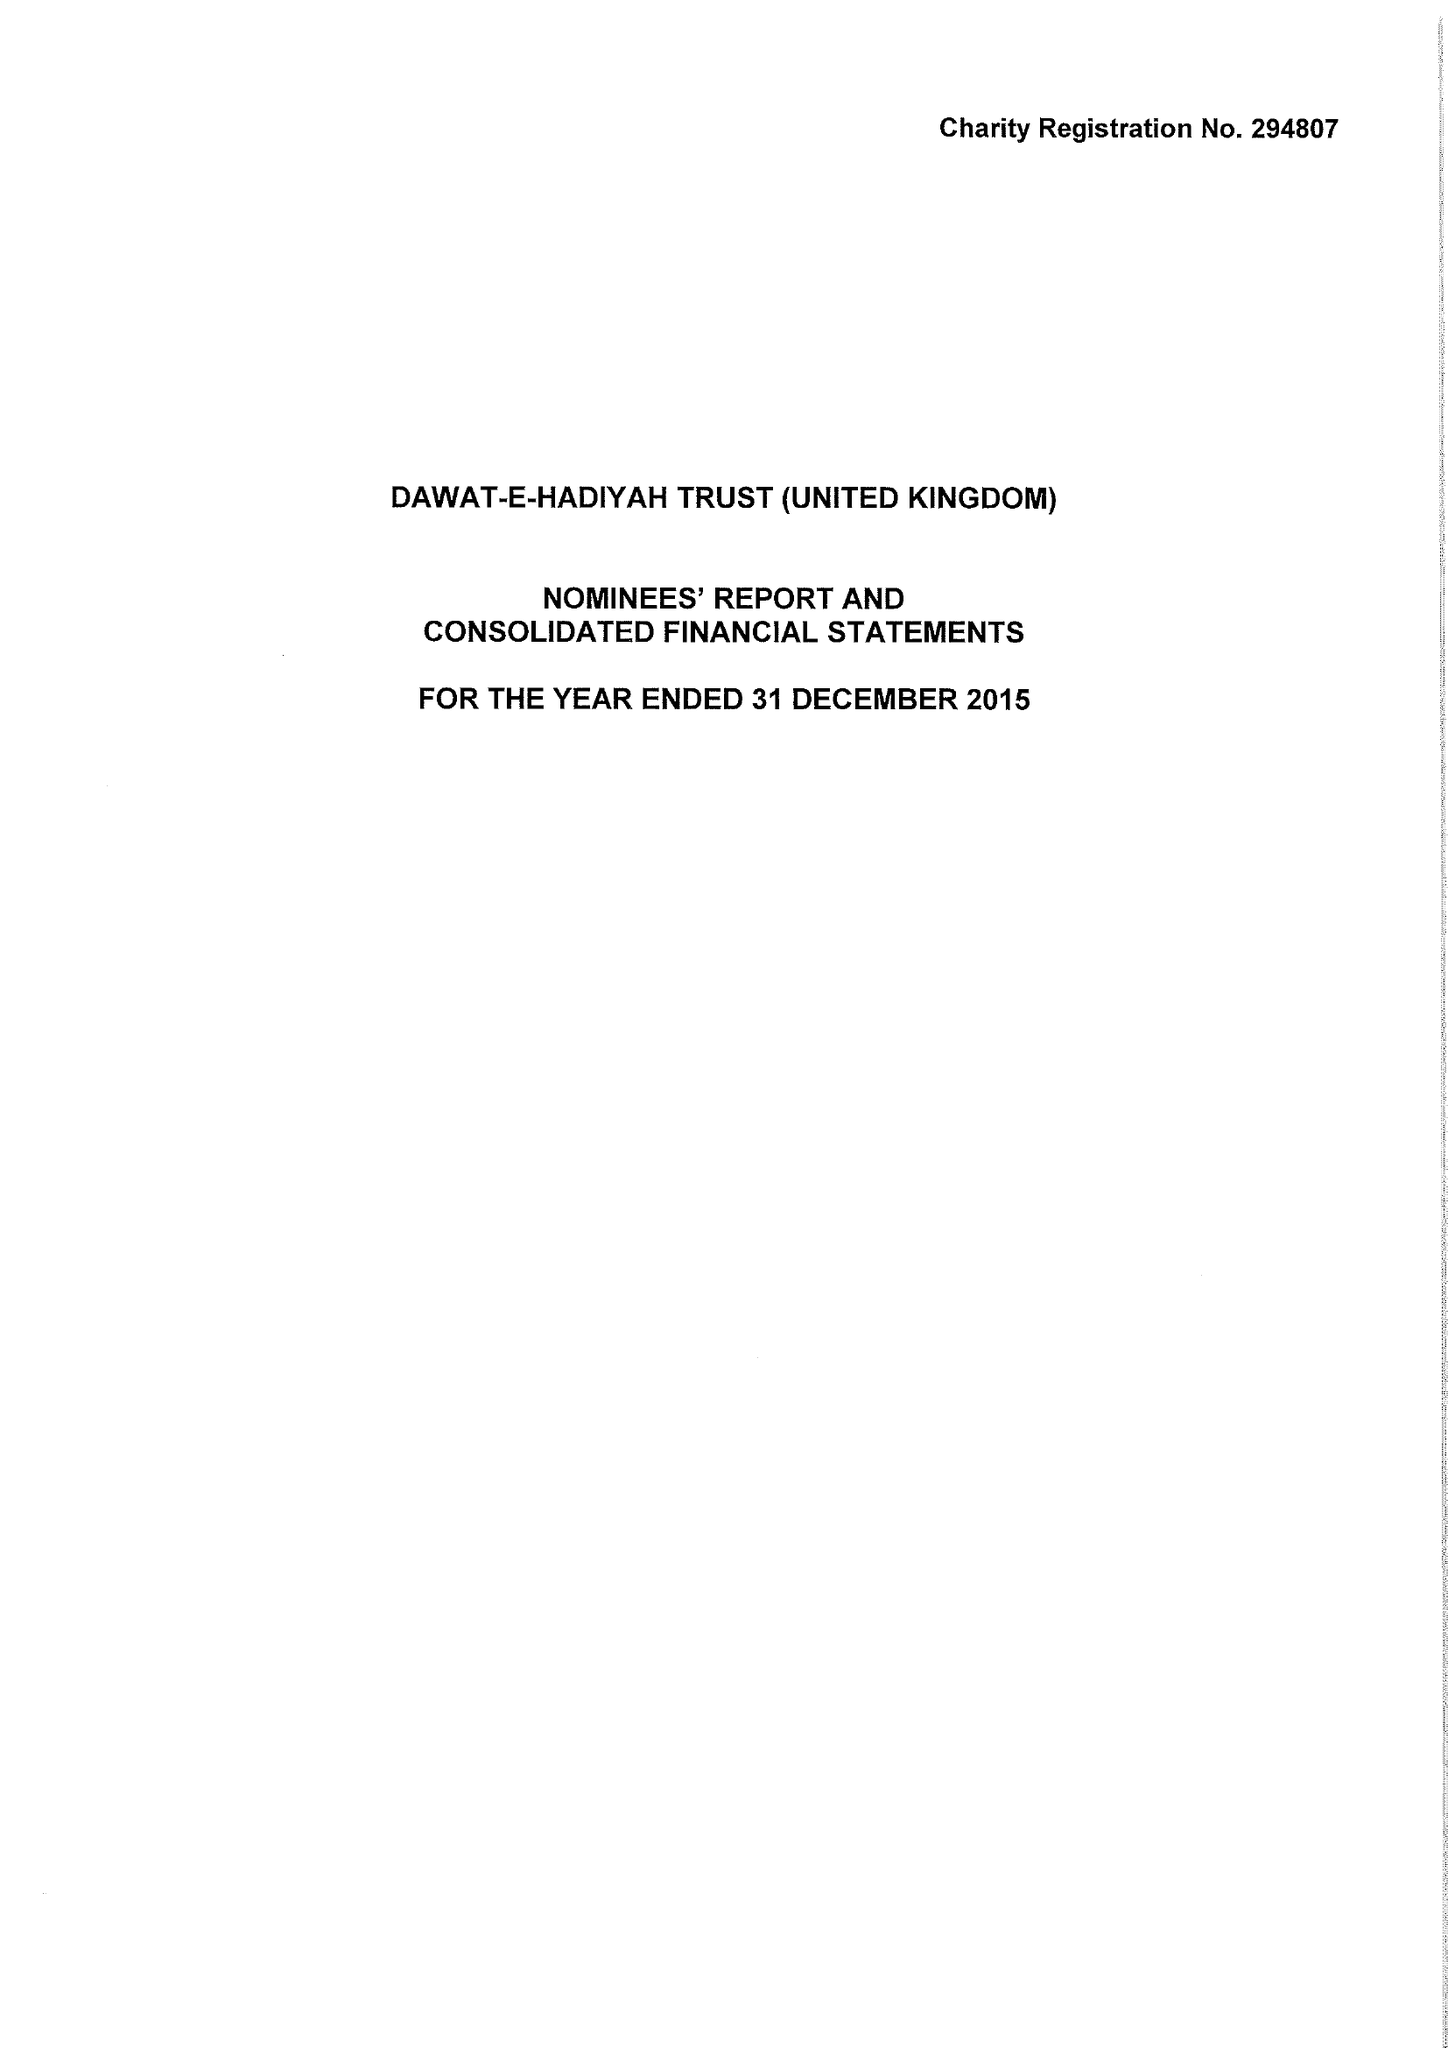What is the value for the address__post_town?
Answer the question using a single word or phrase. GREENFORD 